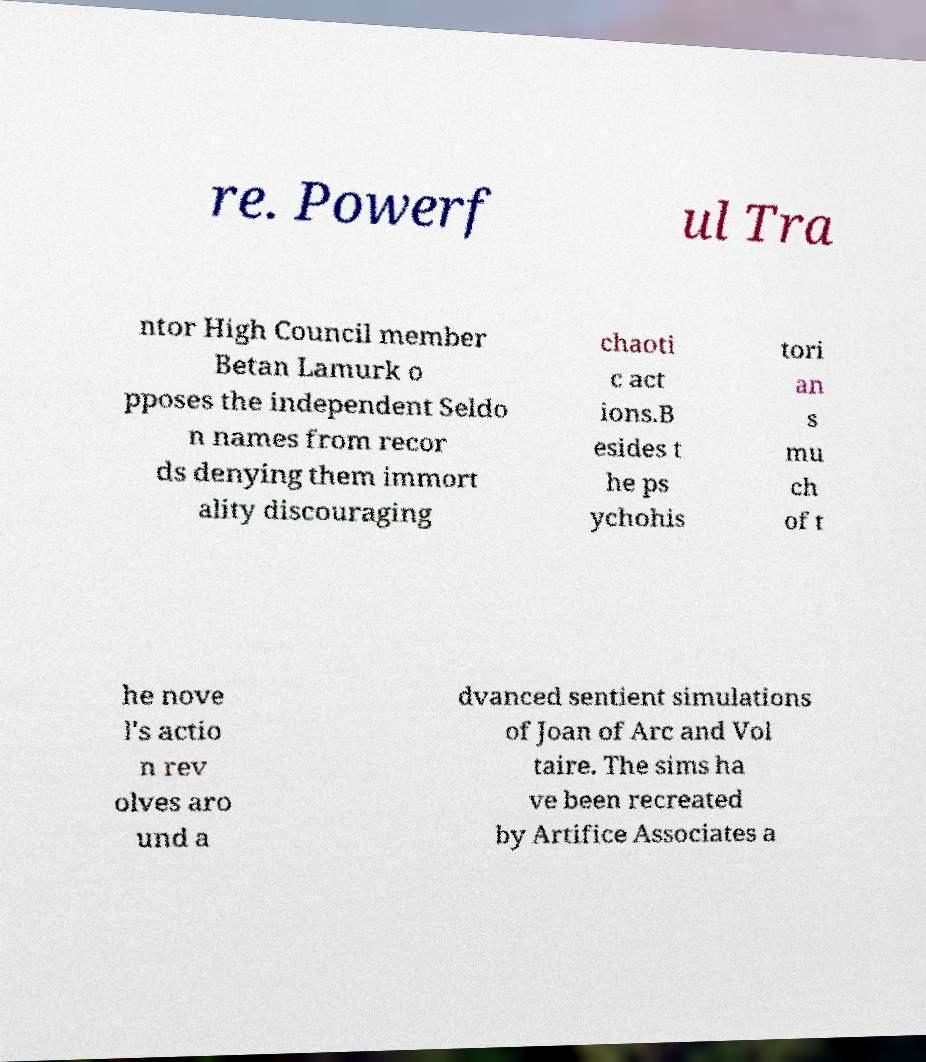Can you accurately transcribe the text from the provided image for me? re. Powerf ul Tra ntor High Council member Betan Lamurk o pposes the independent Seldo n names from recor ds denying them immort ality discouraging chaoti c act ions.B esides t he ps ychohis tori an s mu ch of t he nove l's actio n rev olves aro und a dvanced sentient simulations of Joan of Arc and Vol taire. The sims ha ve been recreated by Artifice Associates a 